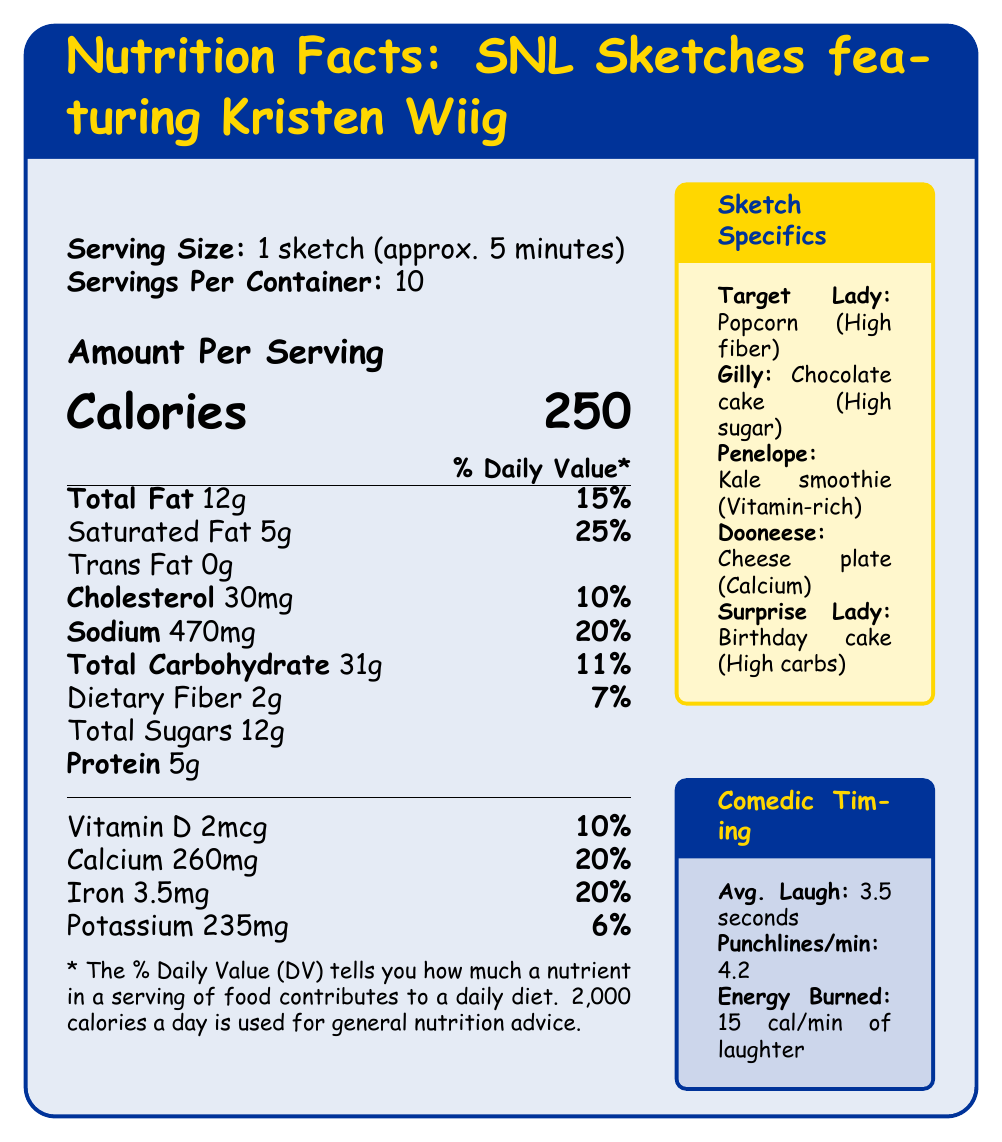what is the serving size for one sketch? The serving size is clearly indicated at the top of the nutritional facts as "1 sketch (approx. 5 minutes)".
Answer: 1 sketch (approx. 5 minutes) how many calories are in one serving of a sketch? The document states the amount per serving for calories as 250.
Answer: 250 what is the amount of saturated fat in one serving, and what percentage of the daily value does this represent? It is stated under "Total Fat" that there are 5 grams of saturated fat, which represents 25% of the daily value.
Answer: 5g, 25% what foods and nutritional highlights are associated with the "Gilly" sketch? The "Sketch Specifics" section lists "Gilly" as featuring chocolate cake, which is high in sugar and saturated fat.
Answer: Chocolate cake; high in sugar and saturated fat which sketch features a food that is high in fiber and low in calories? The "Sketch Specifics" section indicates that the "Target Lady" sketch features popcorn, which is high in fiber and low in calories.
Answer: Target Lady what is the total amount of dietary fiber in one serving? Total dietary fiber per serving is listed as 2 grams.
Answer: 2g does the document specify how much trans fat is in one serving? The document lists 0 grams of trans fat under "Total Fat".
Answer: Yes how many nutrients are detailed in terms of percentage daily value? The nutrients listed with percentage daily values are Total Fat, Saturated Fat, Cholesterol, Sodium, Total Carbohydrate, Dietary Fiber, Vitamin D, Calcium, Iron, and Potassium.
Answer: 10 which sketch features a birthday cake, and what is its nutritional highlight? A. Target Lady B. Gilly C. Penelope D. Surprise Lady The "Sketch Specifics" section shows "Surprise Lady" as featuring a birthday cake, which is high in carbohydrates and added sugars.
Answer: D. Surprise Lady which nutrient contributes the most to the daily value percentage? A. Saturated Fat B. Protein C. Dietary Fiber D. Vitamin D Saturated Fat contributes 25% to the daily value, the highest percentage among the listed nutrients.
Answer: A. Saturated Fat is the average laugh duration longer than 3 seconds according to the document? The document states that the average laugh duration is 3.5 seconds.
Answer: Yes summarize the main idea of the document. The document humorously breaks down the nutritional value of foods seen in Kristen Wiig's SNL sketches and assesses comedic timing statistics like laugh duration and energy expenditure.
Answer: The document provides a fun nutritional analysis of various foods featured in Kristen Wiig's memorable SNL sketches. It includes detailed nutritional information on serving size, calories, fats, cholesterol, sodium, carbohydrates, and protein. Specific sketch information highlights the nutritional attributes of featured foods, while there's also data on comedic timing, such as average laugh duration, punchlines per minute, and calories burned by laughter. how many calories are burned per minute of laughter as per the comedic timing analysis? The "Comedic Timing" section specifies that 15 calories are burned per minute of laughter.
Answer: 15 calories which sketch records the highest intake of Vitamin D, and how much is this as a percentage of the daily value? The "Sketch Specifics" section states that the kale smoothie in the "Penelope" sketch is rich in vitamins A, C, and K, contributing 10% of the daily value in Vitamin D.
Answer: Penelope; 10% what type of nutrient is not listed in the document under vitamins and minerals? Zinc is not mentioned under the vitamins and minerals section in the document.
Answer: Zinc how much Cholesterol does one sketch have? The document lists 30mg of cholesterol.
Answer: 30mg how much protein is in a serving? The amount per serving for protein is 5 grams.
Answer: 5g can we determine the exact energy expenditure of an entire 5-minute sketch based on the document? The document provides energy expenditure in terms of calories burned per minute of laughter but does not specify the total laughter duration in a 5-minute sketch.
Answer: No 